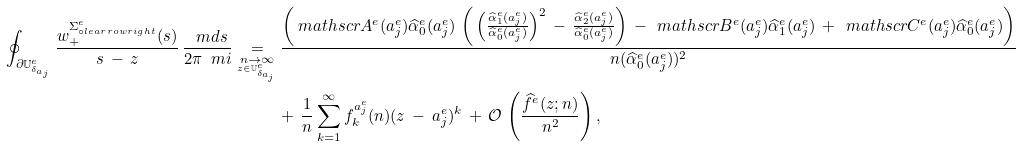Convert formula to latex. <formula><loc_0><loc_0><loc_500><loc_500>\oint _ { \partial \mathbb { U } ^ { e } _ { \delta _ { a _ { j } } } } \frac { w _ { + } ^ { \Sigma ^ { e } _ { \circ l e a r r o w r i g h t } } ( s ) } { s \, - \, z } \, \frac { \ m d s } { 2 \pi \ m i } \underset { \underset { z \in \mathbb { U } ^ { e } _ { \delta _ { a _ { j } } } } { n \to \infty } } { = } & \, \frac { \left ( \ m a t h s c r { A } ^ { e } ( a _ { j } ^ { e } ) \widehat { \alpha } _ { 0 } ^ { e } ( a _ { j } ^ { e } ) \, \left ( \, \left ( \frac { \widehat { \alpha } _ { 1 } ^ { e } ( a _ { j } ^ { e } ) } { \widehat { \alpha } _ { 0 } ^ { e } ( a _ { j } ^ { e } ) } \right ) ^ { 2 } \, - \, \frac { \widehat { \alpha } _ { 2 } ^ { e } ( a _ { j } ^ { e } ) } { \widehat { \alpha } _ { 0 } ^ { e } ( a _ { j } ^ { e } ) } \right ) \, - \, \ m a t h s c r { B } ^ { e } ( a _ { j } ^ { e } ) \widehat { \alpha } _ { 1 } ^ { e } ( a _ { j } ^ { e } ) \, + \, \ m a t h s c r { C } ^ { e } ( a _ { j } ^ { e } ) \widehat { \alpha } _ { 0 } ^ { e } ( a _ { j } ^ { e } ) \right ) } { n ( \widehat { \alpha } _ { 0 } ^ { e } ( a _ { j } ^ { e } ) ) ^ { 2 } } \\ & + \, \frac { 1 } { n } \sum _ { k = 1 } ^ { \infty } f _ { k } ^ { a _ { j } ^ { e } } ( n ) ( z \, - \, a _ { j } ^ { e } ) ^ { k } \, + \, \mathcal { O } \, \left ( \frac { \widehat { f } ^ { e } ( z ; n ) } { n ^ { 2 } } \right ) ,</formula> 